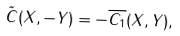Convert formula to latex. <formula><loc_0><loc_0><loc_500><loc_500>\tilde { C } ( X , - Y ) = - \overline { C _ { 1 } } ( X , Y ) ,</formula> 